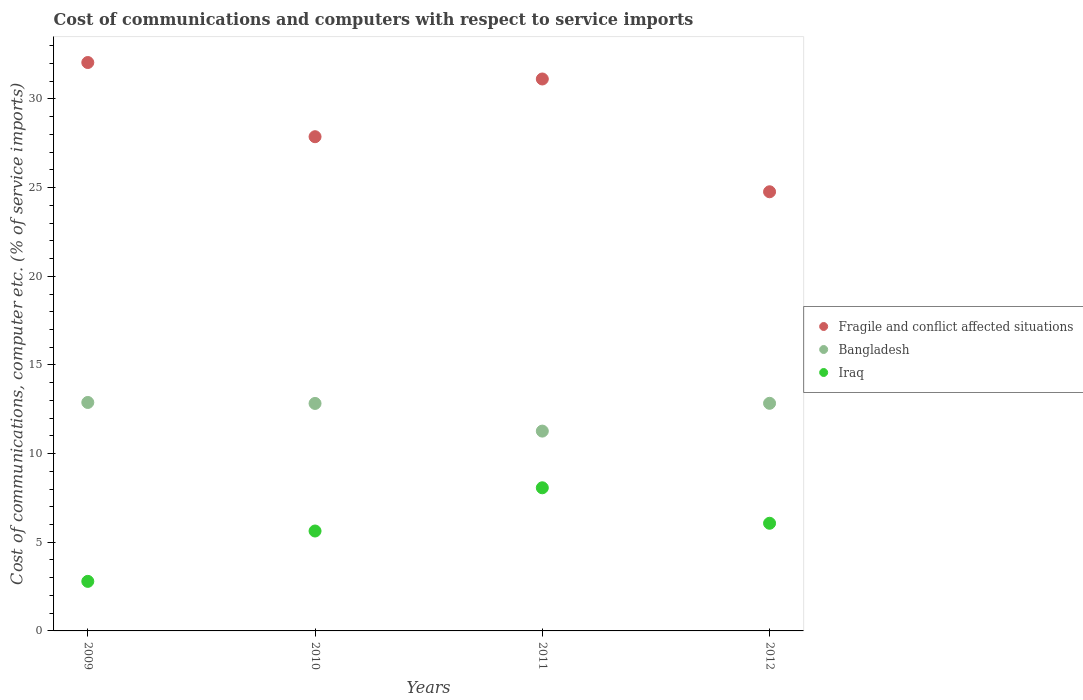Is the number of dotlines equal to the number of legend labels?
Offer a terse response. Yes. What is the cost of communications and computers in Fragile and conflict affected situations in 2011?
Offer a terse response. 31.13. Across all years, what is the maximum cost of communications and computers in Iraq?
Provide a succinct answer. 8.07. Across all years, what is the minimum cost of communications and computers in Bangladesh?
Your answer should be very brief. 11.27. In which year was the cost of communications and computers in Iraq maximum?
Your answer should be very brief. 2011. In which year was the cost of communications and computers in Iraq minimum?
Keep it short and to the point. 2009. What is the total cost of communications and computers in Iraq in the graph?
Make the answer very short. 22.57. What is the difference between the cost of communications and computers in Bangladesh in 2010 and that in 2011?
Your answer should be very brief. 1.56. What is the difference between the cost of communications and computers in Iraq in 2012 and the cost of communications and computers in Fragile and conflict affected situations in 2010?
Keep it short and to the point. -21.8. What is the average cost of communications and computers in Bangladesh per year?
Provide a succinct answer. 12.46. In the year 2010, what is the difference between the cost of communications and computers in Iraq and cost of communications and computers in Bangladesh?
Provide a short and direct response. -7.19. What is the ratio of the cost of communications and computers in Fragile and conflict affected situations in 2009 to that in 2010?
Your answer should be very brief. 1.15. Is the difference between the cost of communications and computers in Iraq in 2009 and 2011 greater than the difference between the cost of communications and computers in Bangladesh in 2009 and 2011?
Give a very brief answer. No. What is the difference between the highest and the second highest cost of communications and computers in Fragile and conflict affected situations?
Give a very brief answer. 0.93. What is the difference between the highest and the lowest cost of communications and computers in Fragile and conflict affected situations?
Your answer should be very brief. 7.29. Is the sum of the cost of communications and computers in Fragile and conflict affected situations in 2009 and 2011 greater than the maximum cost of communications and computers in Bangladesh across all years?
Offer a very short reply. Yes. Is it the case that in every year, the sum of the cost of communications and computers in Fragile and conflict affected situations and cost of communications and computers in Iraq  is greater than the cost of communications and computers in Bangladesh?
Provide a succinct answer. Yes. Is the cost of communications and computers in Bangladesh strictly greater than the cost of communications and computers in Iraq over the years?
Your answer should be compact. Yes. How many dotlines are there?
Give a very brief answer. 3. How many years are there in the graph?
Offer a very short reply. 4. What is the difference between two consecutive major ticks on the Y-axis?
Your answer should be compact. 5. Does the graph contain any zero values?
Ensure brevity in your answer.  No. Does the graph contain grids?
Give a very brief answer. No. Where does the legend appear in the graph?
Provide a short and direct response. Center right. How many legend labels are there?
Keep it short and to the point. 3. How are the legend labels stacked?
Offer a very short reply. Vertical. What is the title of the graph?
Give a very brief answer. Cost of communications and computers with respect to service imports. What is the label or title of the X-axis?
Offer a very short reply. Years. What is the label or title of the Y-axis?
Your answer should be compact. Cost of communications, computer etc. (% of service imports). What is the Cost of communications, computer etc. (% of service imports) of Fragile and conflict affected situations in 2009?
Offer a very short reply. 32.06. What is the Cost of communications, computer etc. (% of service imports) in Bangladesh in 2009?
Ensure brevity in your answer.  12.88. What is the Cost of communications, computer etc. (% of service imports) in Iraq in 2009?
Offer a very short reply. 2.79. What is the Cost of communications, computer etc. (% of service imports) in Fragile and conflict affected situations in 2010?
Your answer should be very brief. 27.87. What is the Cost of communications, computer etc. (% of service imports) in Bangladesh in 2010?
Your response must be concise. 12.83. What is the Cost of communications, computer etc. (% of service imports) of Iraq in 2010?
Your answer should be very brief. 5.63. What is the Cost of communications, computer etc. (% of service imports) in Fragile and conflict affected situations in 2011?
Offer a very short reply. 31.13. What is the Cost of communications, computer etc. (% of service imports) of Bangladesh in 2011?
Make the answer very short. 11.27. What is the Cost of communications, computer etc. (% of service imports) in Iraq in 2011?
Your answer should be compact. 8.07. What is the Cost of communications, computer etc. (% of service imports) of Fragile and conflict affected situations in 2012?
Offer a very short reply. 24.77. What is the Cost of communications, computer etc. (% of service imports) of Bangladesh in 2012?
Offer a very short reply. 12.84. What is the Cost of communications, computer etc. (% of service imports) in Iraq in 2012?
Your answer should be very brief. 6.07. Across all years, what is the maximum Cost of communications, computer etc. (% of service imports) in Fragile and conflict affected situations?
Provide a short and direct response. 32.06. Across all years, what is the maximum Cost of communications, computer etc. (% of service imports) of Bangladesh?
Keep it short and to the point. 12.88. Across all years, what is the maximum Cost of communications, computer etc. (% of service imports) of Iraq?
Ensure brevity in your answer.  8.07. Across all years, what is the minimum Cost of communications, computer etc. (% of service imports) in Fragile and conflict affected situations?
Make the answer very short. 24.77. Across all years, what is the minimum Cost of communications, computer etc. (% of service imports) in Bangladesh?
Keep it short and to the point. 11.27. Across all years, what is the minimum Cost of communications, computer etc. (% of service imports) in Iraq?
Offer a terse response. 2.79. What is the total Cost of communications, computer etc. (% of service imports) of Fragile and conflict affected situations in the graph?
Provide a succinct answer. 115.82. What is the total Cost of communications, computer etc. (% of service imports) of Bangladesh in the graph?
Your answer should be compact. 49.82. What is the total Cost of communications, computer etc. (% of service imports) in Iraq in the graph?
Your answer should be very brief. 22.57. What is the difference between the Cost of communications, computer etc. (% of service imports) in Fragile and conflict affected situations in 2009 and that in 2010?
Make the answer very short. 4.18. What is the difference between the Cost of communications, computer etc. (% of service imports) in Bangladesh in 2009 and that in 2010?
Make the answer very short. 0.06. What is the difference between the Cost of communications, computer etc. (% of service imports) of Iraq in 2009 and that in 2010?
Your answer should be compact. -2.84. What is the difference between the Cost of communications, computer etc. (% of service imports) in Fragile and conflict affected situations in 2009 and that in 2011?
Provide a short and direct response. 0.93. What is the difference between the Cost of communications, computer etc. (% of service imports) in Bangladesh in 2009 and that in 2011?
Give a very brief answer. 1.62. What is the difference between the Cost of communications, computer etc. (% of service imports) of Iraq in 2009 and that in 2011?
Your response must be concise. -5.28. What is the difference between the Cost of communications, computer etc. (% of service imports) of Fragile and conflict affected situations in 2009 and that in 2012?
Keep it short and to the point. 7.29. What is the difference between the Cost of communications, computer etc. (% of service imports) of Bangladesh in 2009 and that in 2012?
Your answer should be compact. 0.05. What is the difference between the Cost of communications, computer etc. (% of service imports) in Iraq in 2009 and that in 2012?
Offer a very short reply. -3.28. What is the difference between the Cost of communications, computer etc. (% of service imports) in Fragile and conflict affected situations in 2010 and that in 2011?
Ensure brevity in your answer.  -3.26. What is the difference between the Cost of communications, computer etc. (% of service imports) of Bangladesh in 2010 and that in 2011?
Keep it short and to the point. 1.56. What is the difference between the Cost of communications, computer etc. (% of service imports) in Iraq in 2010 and that in 2011?
Your answer should be compact. -2.44. What is the difference between the Cost of communications, computer etc. (% of service imports) of Fragile and conflict affected situations in 2010 and that in 2012?
Provide a short and direct response. 3.11. What is the difference between the Cost of communications, computer etc. (% of service imports) in Bangladesh in 2010 and that in 2012?
Provide a short and direct response. -0.01. What is the difference between the Cost of communications, computer etc. (% of service imports) in Iraq in 2010 and that in 2012?
Make the answer very short. -0.44. What is the difference between the Cost of communications, computer etc. (% of service imports) in Fragile and conflict affected situations in 2011 and that in 2012?
Provide a short and direct response. 6.36. What is the difference between the Cost of communications, computer etc. (% of service imports) in Bangladesh in 2011 and that in 2012?
Keep it short and to the point. -1.57. What is the difference between the Cost of communications, computer etc. (% of service imports) of Iraq in 2011 and that in 2012?
Your response must be concise. 2. What is the difference between the Cost of communications, computer etc. (% of service imports) of Fragile and conflict affected situations in 2009 and the Cost of communications, computer etc. (% of service imports) of Bangladesh in 2010?
Keep it short and to the point. 19.23. What is the difference between the Cost of communications, computer etc. (% of service imports) in Fragile and conflict affected situations in 2009 and the Cost of communications, computer etc. (% of service imports) in Iraq in 2010?
Your answer should be very brief. 26.42. What is the difference between the Cost of communications, computer etc. (% of service imports) in Bangladesh in 2009 and the Cost of communications, computer etc. (% of service imports) in Iraq in 2010?
Offer a very short reply. 7.25. What is the difference between the Cost of communications, computer etc. (% of service imports) of Fragile and conflict affected situations in 2009 and the Cost of communications, computer etc. (% of service imports) of Bangladesh in 2011?
Provide a short and direct response. 20.79. What is the difference between the Cost of communications, computer etc. (% of service imports) of Fragile and conflict affected situations in 2009 and the Cost of communications, computer etc. (% of service imports) of Iraq in 2011?
Your answer should be compact. 23.98. What is the difference between the Cost of communications, computer etc. (% of service imports) in Bangladesh in 2009 and the Cost of communications, computer etc. (% of service imports) in Iraq in 2011?
Offer a terse response. 4.81. What is the difference between the Cost of communications, computer etc. (% of service imports) of Fragile and conflict affected situations in 2009 and the Cost of communications, computer etc. (% of service imports) of Bangladesh in 2012?
Offer a very short reply. 19.22. What is the difference between the Cost of communications, computer etc. (% of service imports) in Fragile and conflict affected situations in 2009 and the Cost of communications, computer etc. (% of service imports) in Iraq in 2012?
Give a very brief answer. 25.99. What is the difference between the Cost of communications, computer etc. (% of service imports) in Bangladesh in 2009 and the Cost of communications, computer etc. (% of service imports) in Iraq in 2012?
Your response must be concise. 6.81. What is the difference between the Cost of communications, computer etc. (% of service imports) of Fragile and conflict affected situations in 2010 and the Cost of communications, computer etc. (% of service imports) of Bangladesh in 2011?
Give a very brief answer. 16.6. What is the difference between the Cost of communications, computer etc. (% of service imports) in Fragile and conflict affected situations in 2010 and the Cost of communications, computer etc. (% of service imports) in Iraq in 2011?
Provide a succinct answer. 19.8. What is the difference between the Cost of communications, computer etc. (% of service imports) in Bangladesh in 2010 and the Cost of communications, computer etc. (% of service imports) in Iraq in 2011?
Your response must be concise. 4.76. What is the difference between the Cost of communications, computer etc. (% of service imports) of Fragile and conflict affected situations in 2010 and the Cost of communications, computer etc. (% of service imports) of Bangladesh in 2012?
Your response must be concise. 15.04. What is the difference between the Cost of communications, computer etc. (% of service imports) in Fragile and conflict affected situations in 2010 and the Cost of communications, computer etc. (% of service imports) in Iraq in 2012?
Offer a terse response. 21.8. What is the difference between the Cost of communications, computer etc. (% of service imports) of Bangladesh in 2010 and the Cost of communications, computer etc. (% of service imports) of Iraq in 2012?
Provide a short and direct response. 6.76. What is the difference between the Cost of communications, computer etc. (% of service imports) of Fragile and conflict affected situations in 2011 and the Cost of communications, computer etc. (% of service imports) of Bangladesh in 2012?
Give a very brief answer. 18.29. What is the difference between the Cost of communications, computer etc. (% of service imports) in Fragile and conflict affected situations in 2011 and the Cost of communications, computer etc. (% of service imports) in Iraq in 2012?
Offer a terse response. 25.06. What is the difference between the Cost of communications, computer etc. (% of service imports) of Bangladesh in 2011 and the Cost of communications, computer etc. (% of service imports) of Iraq in 2012?
Your response must be concise. 5.2. What is the average Cost of communications, computer etc. (% of service imports) in Fragile and conflict affected situations per year?
Provide a short and direct response. 28.96. What is the average Cost of communications, computer etc. (% of service imports) in Bangladesh per year?
Keep it short and to the point. 12.46. What is the average Cost of communications, computer etc. (% of service imports) of Iraq per year?
Provide a short and direct response. 5.64. In the year 2009, what is the difference between the Cost of communications, computer etc. (% of service imports) in Fragile and conflict affected situations and Cost of communications, computer etc. (% of service imports) in Bangladesh?
Make the answer very short. 19.17. In the year 2009, what is the difference between the Cost of communications, computer etc. (% of service imports) of Fragile and conflict affected situations and Cost of communications, computer etc. (% of service imports) of Iraq?
Offer a terse response. 29.26. In the year 2009, what is the difference between the Cost of communications, computer etc. (% of service imports) in Bangladesh and Cost of communications, computer etc. (% of service imports) in Iraq?
Your answer should be very brief. 10.09. In the year 2010, what is the difference between the Cost of communications, computer etc. (% of service imports) of Fragile and conflict affected situations and Cost of communications, computer etc. (% of service imports) of Bangladesh?
Your answer should be very brief. 15.04. In the year 2010, what is the difference between the Cost of communications, computer etc. (% of service imports) of Fragile and conflict affected situations and Cost of communications, computer etc. (% of service imports) of Iraq?
Provide a short and direct response. 22.24. In the year 2010, what is the difference between the Cost of communications, computer etc. (% of service imports) in Bangladesh and Cost of communications, computer etc. (% of service imports) in Iraq?
Your answer should be very brief. 7.19. In the year 2011, what is the difference between the Cost of communications, computer etc. (% of service imports) in Fragile and conflict affected situations and Cost of communications, computer etc. (% of service imports) in Bangladesh?
Provide a short and direct response. 19.86. In the year 2011, what is the difference between the Cost of communications, computer etc. (% of service imports) in Fragile and conflict affected situations and Cost of communications, computer etc. (% of service imports) in Iraq?
Your response must be concise. 23.06. In the year 2011, what is the difference between the Cost of communications, computer etc. (% of service imports) of Bangladesh and Cost of communications, computer etc. (% of service imports) of Iraq?
Your answer should be very brief. 3.2. In the year 2012, what is the difference between the Cost of communications, computer etc. (% of service imports) of Fragile and conflict affected situations and Cost of communications, computer etc. (% of service imports) of Bangladesh?
Keep it short and to the point. 11.93. In the year 2012, what is the difference between the Cost of communications, computer etc. (% of service imports) in Fragile and conflict affected situations and Cost of communications, computer etc. (% of service imports) in Iraq?
Offer a terse response. 18.7. In the year 2012, what is the difference between the Cost of communications, computer etc. (% of service imports) of Bangladesh and Cost of communications, computer etc. (% of service imports) of Iraq?
Ensure brevity in your answer.  6.77. What is the ratio of the Cost of communications, computer etc. (% of service imports) in Fragile and conflict affected situations in 2009 to that in 2010?
Keep it short and to the point. 1.15. What is the ratio of the Cost of communications, computer etc. (% of service imports) in Iraq in 2009 to that in 2010?
Ensure brevity in your answer.  0.5. What is the ratio of the Cost of communications, computer etc. (% of service imports) in Fragile and conflict affected situations in 2009 to that in 2011?
Offer a very short reply. 1.03. What is the ratio of the Cost of communications, computer etc. (% of service imports) in Bangladesh in 2009 to that in 2011?
Offer a very short reply. 1.14. What is the ratio of the Cost of communications, computer etc. (% of service imports) of Iraq in 2009 to that in 2011?
Your answer should be very brief. 0.35. What is the ratio of the Cost of communications, computer etc. (% of service imports) in Fragile and conflict affected situations in 2009 to that in 2012?
Your answer should be compact. 1.29. What is the ratio of the Cost of communications, computer etc. (% of service imports) in Iraq in 2009 to that in 2012?
Provide a succinct answer. 0.46. What is the ratio of the Cost of communications, computer etc. (% of service imports) in Fragile and conflict affected situations in 2010 to that in 2011?
Provide a short and direct response. 0.9. What is the ratio of the Cost of communications, computer etc. (% of service imports) of Bangladesh in 2010 to that in 2011?
Provide a succinct answer. 1.14. What is the ratio of the Cost of communications, computer etc. (% of service imports) of Iraq in 2010 to that in 2011?
Offer a terse response. 0.7. What is the ratio of the Cost of communications, computer etc. (% of service imports) of Fragile and conflict affected situations in 2010 to that in 2012?
Provide a succinct answer. 1.13. What is the ratio of the Cost of communications, computer etc. (% of service imports) of Bangladesh in 2010 to that in 2012?
Offer a terse response. 1. What is the ratio of the Cost of communications, computer etc. (% of service imports) in Iraq in 2010 to that in 2012?
Your response must be concise. 0.93. What is the ratio of the Cost of communications, computer etc. (% of service imports) in Fragile and conflict affected situations in 2011 to that in 2012?
Ensure brevity in your answer.  1.26. What is the ratio of the Cost of communications, computer etc. (% of service imports) in Bangladesh in 2011 to that in 2012?
Your answer should be compact. 0.88. What is the ratio of the Cost of communications, computer etc. (% of service imports) of Iraq in 2011 to that in 2012?
Your answer should be compact. 1.33. What is the difference between the highest and the second highest Cost of communications, computer etc. (% of service imports) in Fragile and conflict affected situations?
Keep it short and to the point. 0.93. What is the difference between the highest and the second highest Cost of communications, computer etc. (% of service imports) of Bangladesh?
Offer a very short reply. 0.05. What is the difference between the highest and the second highest Cost of communications, computer etc. (% of service imports) of Iraq?
Your answer should be compact. 2. What is the difference between the highest and the lowest Cost of communications, computer etc. (% of service imports) of Fragile and conflict affected situations?
Your response must be concise. 7.29. What is the difference between the highest and the lowest Cost of communications, computer etc. (% of service imports) of Bangladesh?
Give a very brief answer. 1.62. What is the difference between the highest and the lowest Cost of communications, computer etc. (% of service imports) of Iraq?
Offer a very short reply. 5.28. 